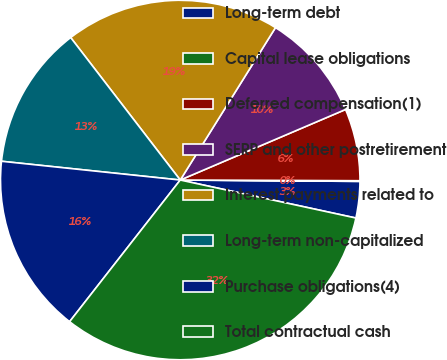<chart> <loc_0><loc_0><loc_500><loc_500><pie_chart><fcel>Long-term debt<fcel>Capital lease obligations<fcel>Deferred compensation(1)<fcel>SERP and other postretirement<fcel>Interest payments related to<fcel>Long-term non-capitalized<fcel>Purchase obligations(4)<fcel>Total contractual cash<nl><fcel>3.27%<fcel>0.06%<fcel>6.48%<fcel>9.69%<fcel>19.32%<fcel>12.9%<fcel>16.11%<fcel>32.16%<nl></chart> 